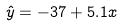<formula> <loc_0><loc_0><loc_500><loc_500>\hat { y } = - 3 7 + 5 . 1 x</formula> 